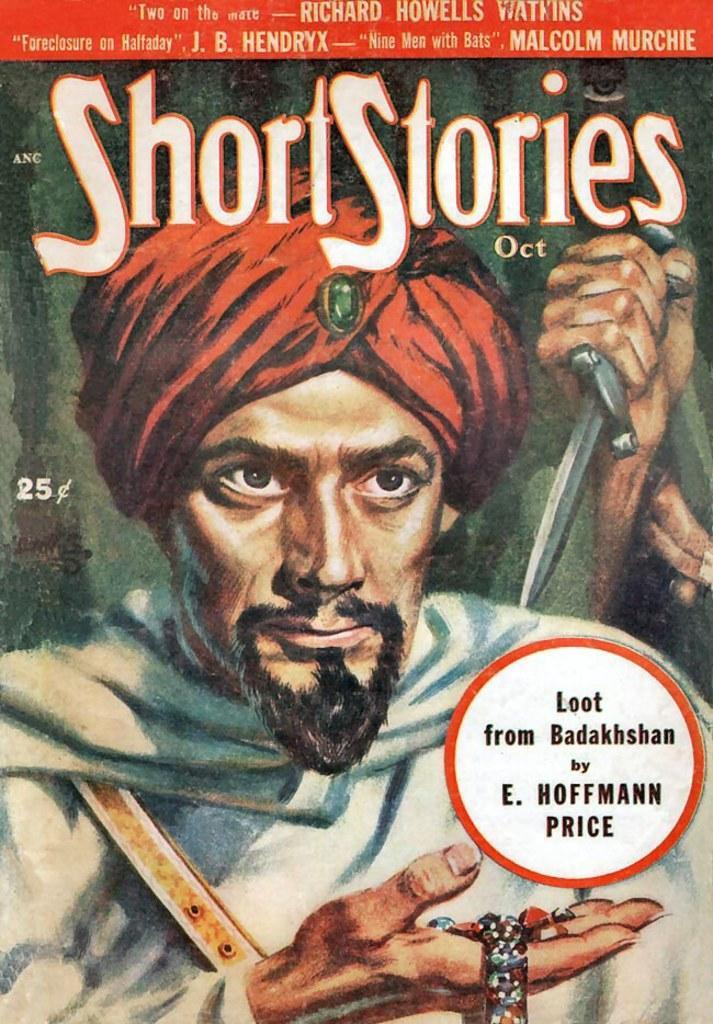Describe this image in one or two sentences. This is an animated image in which there is a person and there is some text written on it. 